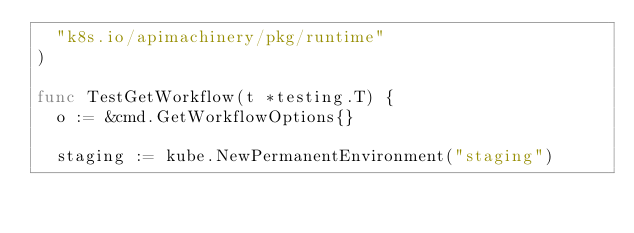Convert code to text. <code><loc_0><loc_0><loc_500><loc_500><_Go_>	"k8s.io/apimachinery/pkg/runtime"
)

func TestGetWorkflow(t *testing.T) {
	o := &cmd.GetWorkflowOptions{}

	staging := kube.NewPermanentEnvironment("staging")</code> 